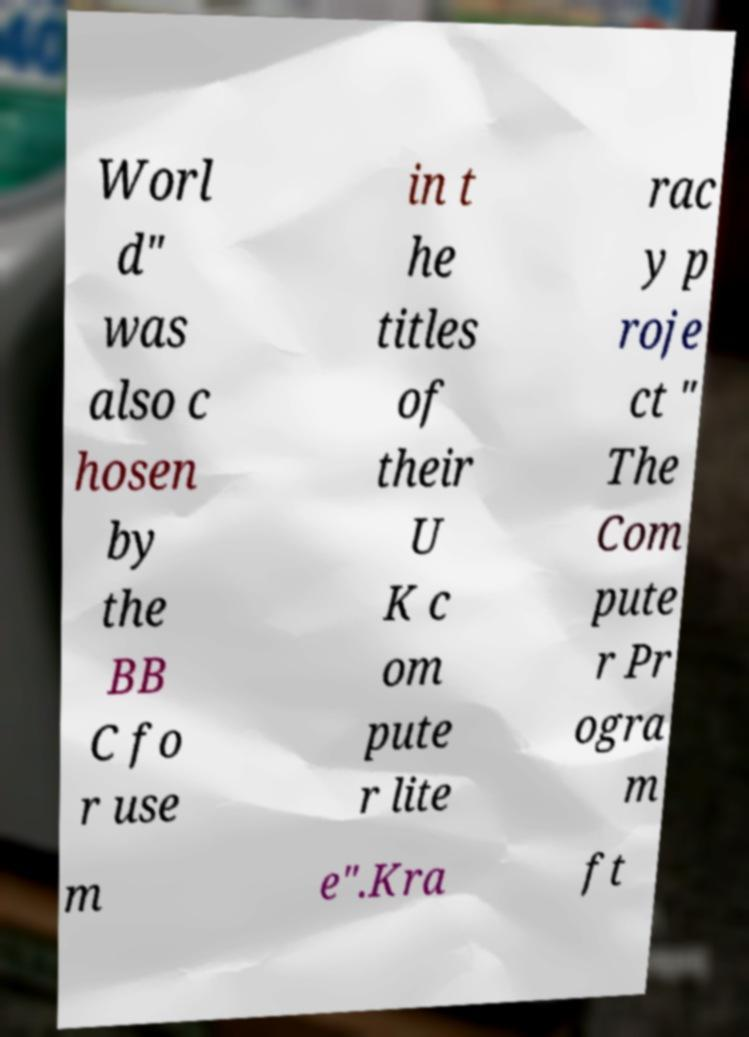For documentation purposes, I need the text within this image transcribed. Could you provide that? Worl d" was also c hosen by the BB C fo r use in t he titles of their U K c om pute r lite rac y p roje ct " The Com pute r Pr ogra m m e".Kra ft 